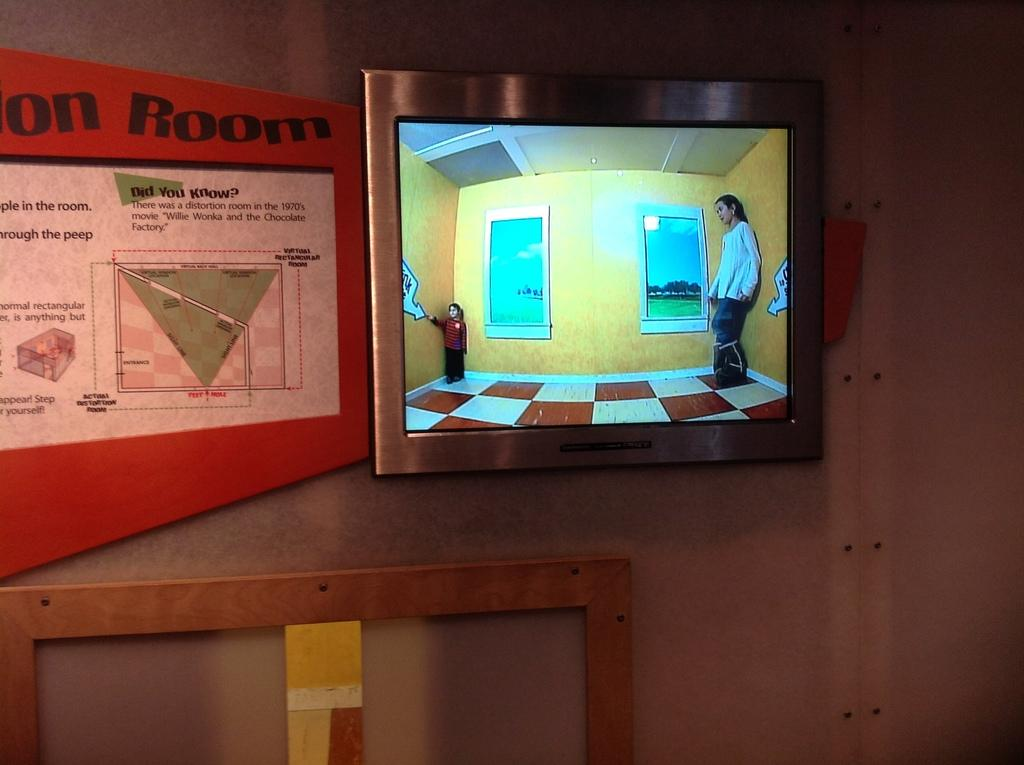What objects are attached to the wall in the image? There are two boards attached to the wall in the image. What is the purpose of the screen on the wall? The purpose of the screen on the wall is not specified in the image. What song is being played by the chickens in the image? There are no chickens present in the image, so there is no song being played by them. 